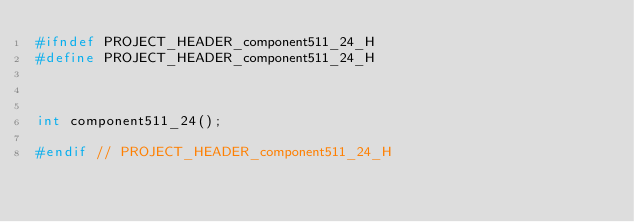<code> <loc_0><loc_0><loc_500><loc_500><_C_>#ifndef PROJECT_HEADER_component511_24_H
#define PROJECT_HEADER_component511_24_H



int component511_24();

#endif // PROJECT_HEADER_component511_24_H</code> 